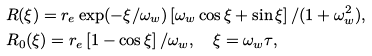Convert formula to latex. <formula><loc_0><loc_0><loc_500><loc_500>& R ( \xi ) = r _ { e } \exp ( - \xi / \omega _ { w } ) \left [ \omega _ { w } \cos \xi + \sin \xi \right ] / ( 1 + \omega _ { w } ^ { 2 } ) , \\ & R _ { 0 } ( \xi ) = r _ { e } \left [ 1 - \cos \xi \right ] / \omega _ { w } , \quad \xi = \omega _ { w } \tau ,</formula> 